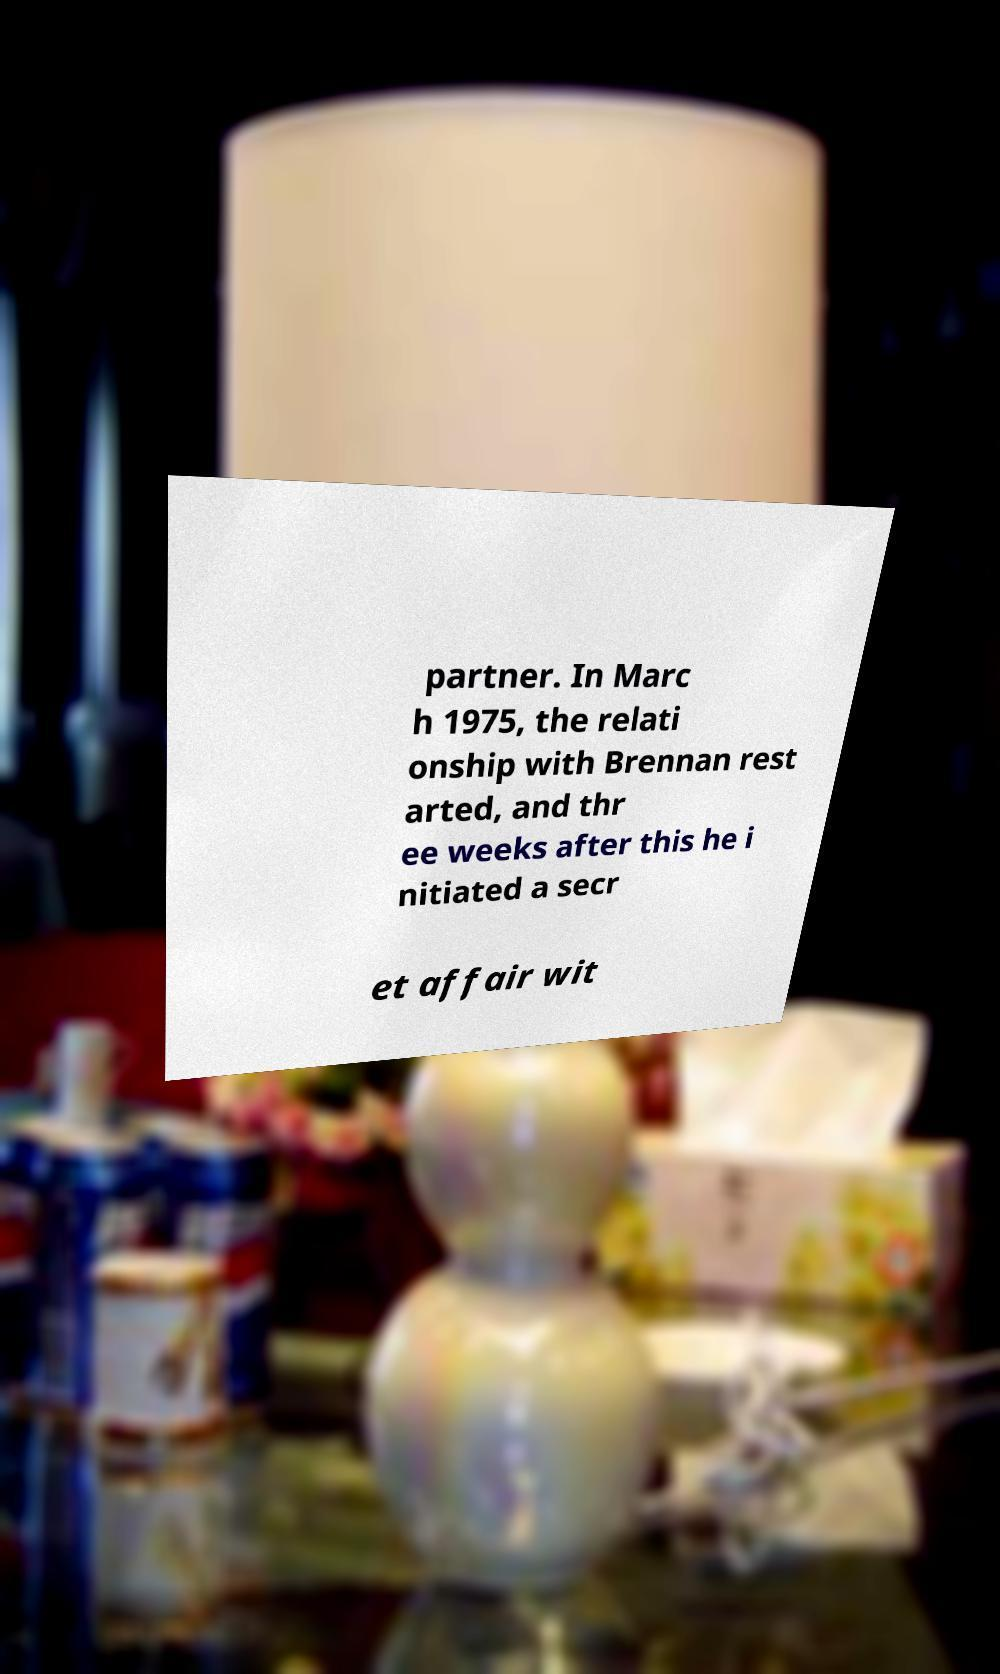For documentation purposes, I need the text within this image transcribed. Could you provide that? partner. In Marc h 1975, the relati onship with Brennan rest arted, and thr ee weeks after this he i nitiated a secr et affair wit 